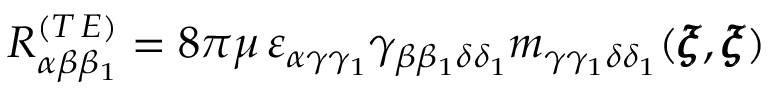<formula> <loc_0><loc_0><loc_500><loc_500>R _ { \alpha \beta \beta _ { 1 } } ^ { ( T \, E ) } = 8 \pi \mu \, \varepsilon _ { \alpha \gamma \gamma _ { 1 } } \gamma _ { \beta \beta _ { 1 } \delta \delta _ { 1 } } m _ { \gamma \gamma _ { 1 } \delta \delta _ { 1 } } ( { \pm b \xi } , { \pm b \xi } )</formula> 